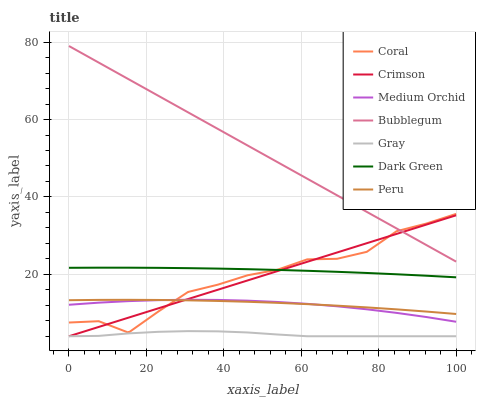Does Gray have the minimum area under the curve?
Answer yes or no. Yes. Does Bubblegum have the maximum area under the curve?
Answer yes or no. Yes. Does Coral have the minimum area under the curve?
Answer yes or no. No. Does Coral have the maximum area under the curve?
Answer yes or no. No. Is Crimson the smoothest?
Answer yes or no. Yes. Is Coral the roughest?
Answer yes or no. Yes. Is Medium Orchid the smoothest?
Answer yes or no. No. Is Medium Orchid the roughest?
Answer yes or no. No. Does Gray have the lowest value?
Answer yes or no. Yes. Does Coral have the lowest value?
Answer yes or no. No. Does Bubblegum have the highest value?
Answer yes or no. Yes. Does Coral have the highest value?
Answer yes or no. No. Is Gray less than Medium Orchid?
Answer yes or no. Yes. Is Dark Green greater than Peru?
Answer yes or no. Yes. Does Crimson intersect Peru?
Answer yes or no. Yes. Is Crimson less than Peru?
Answer yes or no. No. Is Crimson greater than Peru?
Answer yes or no. No. Does Gray intersect Medium Orchid?
Answer yes or no. No. 